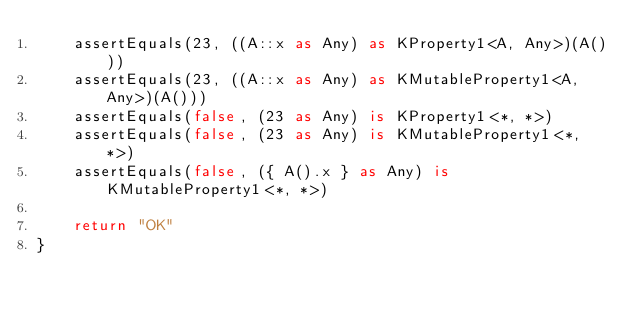Convert code to text. <code><loc_0><loc_0><loc_500><loc_500><_Kotlin_>    assertEquals(23, ((A::x as Any) as KProperty1<A, Any>)(A()))
    assertEquals(23, ((A::x as Any) as KMutableProperty1<A, Any>)(A()))
    assertEquals(false, (23 as Any) is KProperty1<*, *>)
    assertEquals(false, (23 as Any) is KMutableProperty1<*, *>)
    assertEquals(false, ({ A().x } as Any) is KMutableProperty1<*, *>)

    return "OK"
}</code> 